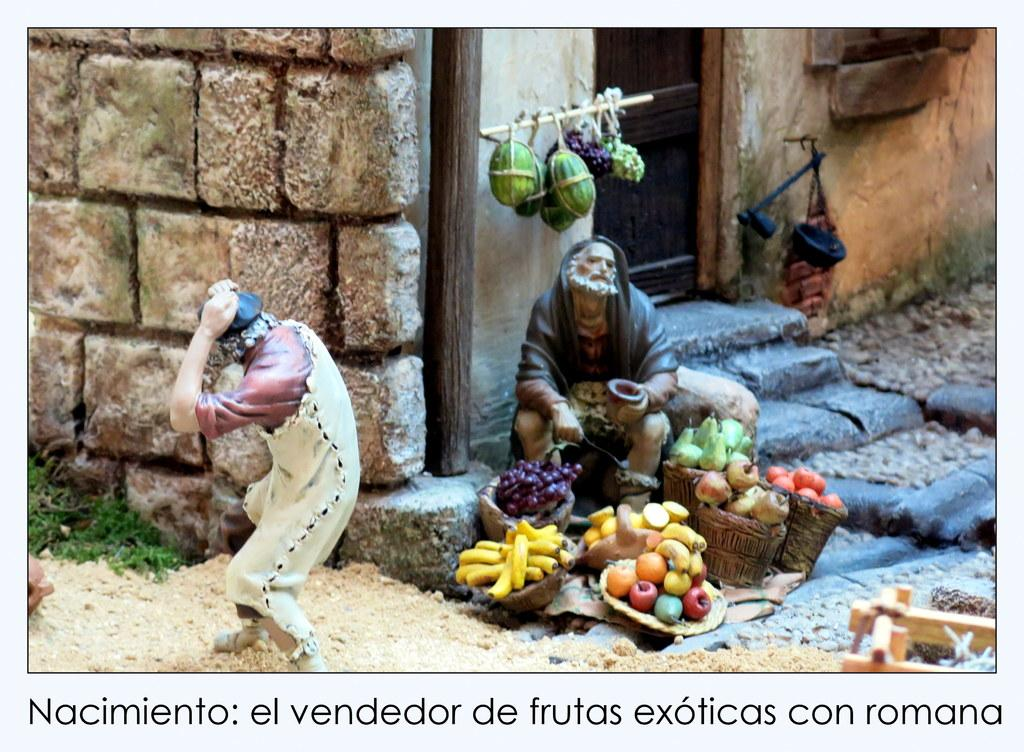What type of image is being described? The image appears to be animated. What objects can be seen in the image? There are sculptures and vegetables in the image. What structures are present in the image? There is a wall and a door in the image. Can you see a snake digesting its meal in the image? There is no snake or any digestion process visible in the image. 